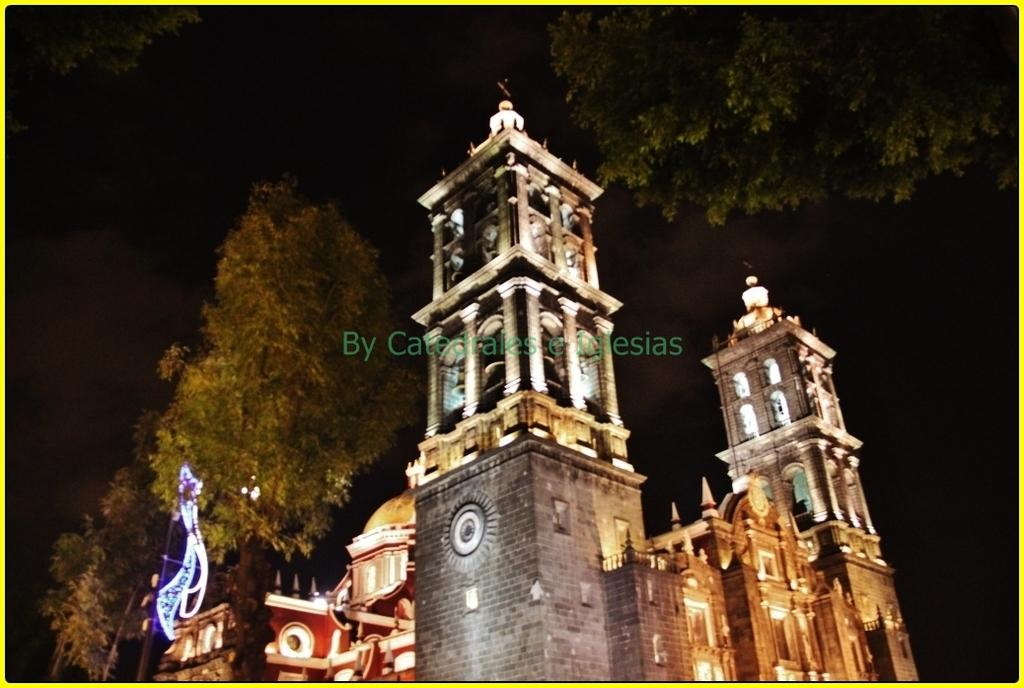What type of building is the main subject of the image? There is a palace in the image. How can you describe the palace's appearance? The palace has many lights. What can be seen in the background of the image? There are trees behind the palace. When was the image taken? The image was taken at night time. How does the palace exchange information with the trees in the image? There is no exchange of information between the palace and the trees in the image, as they are inanimate objects. 